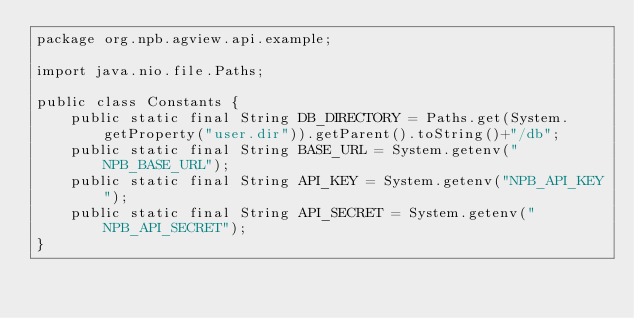Convert code to text. <code><loc_0><loc_0><loc_500><loc_500><_Java_>package org.npb.agview.api.example;

import java.nio.file.Paths;

public class Constants {
    public static final String DB_DIRECTORY = Paths.get(System.getProperty("user.dir")).getParent().toString()+"/db";
    public static final String BASE_URL = System.getenv("NPB_BASE_URL");
    public static final String API_KEY = System.getenv("NPB_API_KEY");
    public static final String API_SECRET = System.getenv("NPB_API_SECRET");
}
</code> 